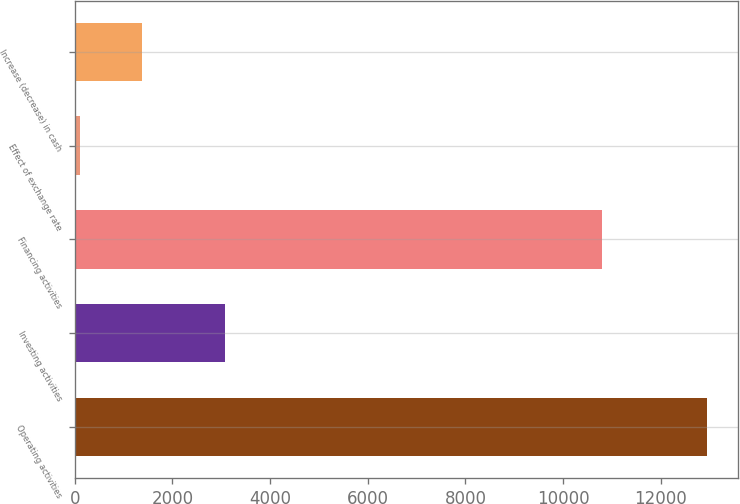Convert chart. <chart><loc_0><loc_0><loc_500><loc_500><bar_chart><fcel>Operating activities<fcel>Investing activities<fcel>Financing activities<fcel>Effect of exchange rate<fcel>Increase (decrease) in cash<nl><fcel>12941<fcel>3084<fcel>10790<fcel>101<fcel>1385<nl></chart> 